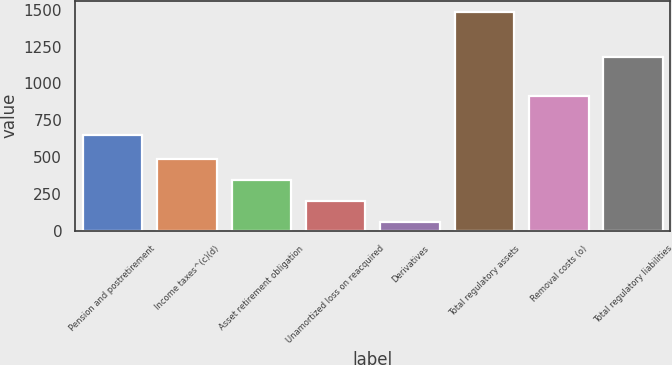<chart> <loc_0><loc_0><loc_500><loc_500><bar_chart><fcel>Pension and postretirement<fcel>Income taxes^(c)(d)<fcel>Asset retirement obligation<fcel>Unamortized loss on reacquired<fcel>Derivatives<fcel>Total regulatory assets<fcel>Removal costs (o)<fcel>Total regulatory liabilities<nl><fcel>647<fcel>486.3<fcel>343.2<fcel>200.1<fcel>57<fcel>1488<fcel>915<fcel>1177<nl></chart> 